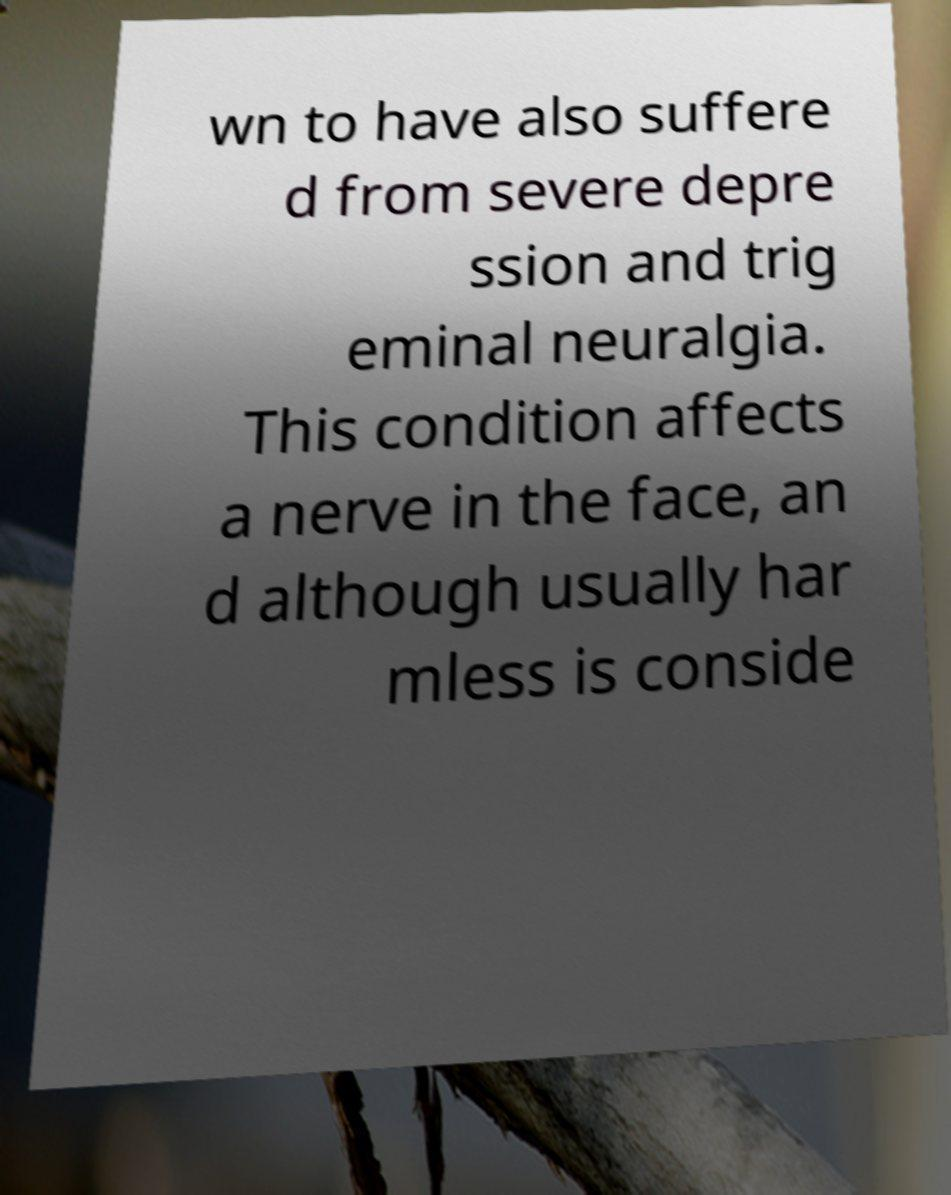Please identify and transcribe the text found in this image. wn to have also suffere d from severe depre ssion and trig eminal neuralgia. This condition affects a nerve in the face, an d although usually har mless is conside 